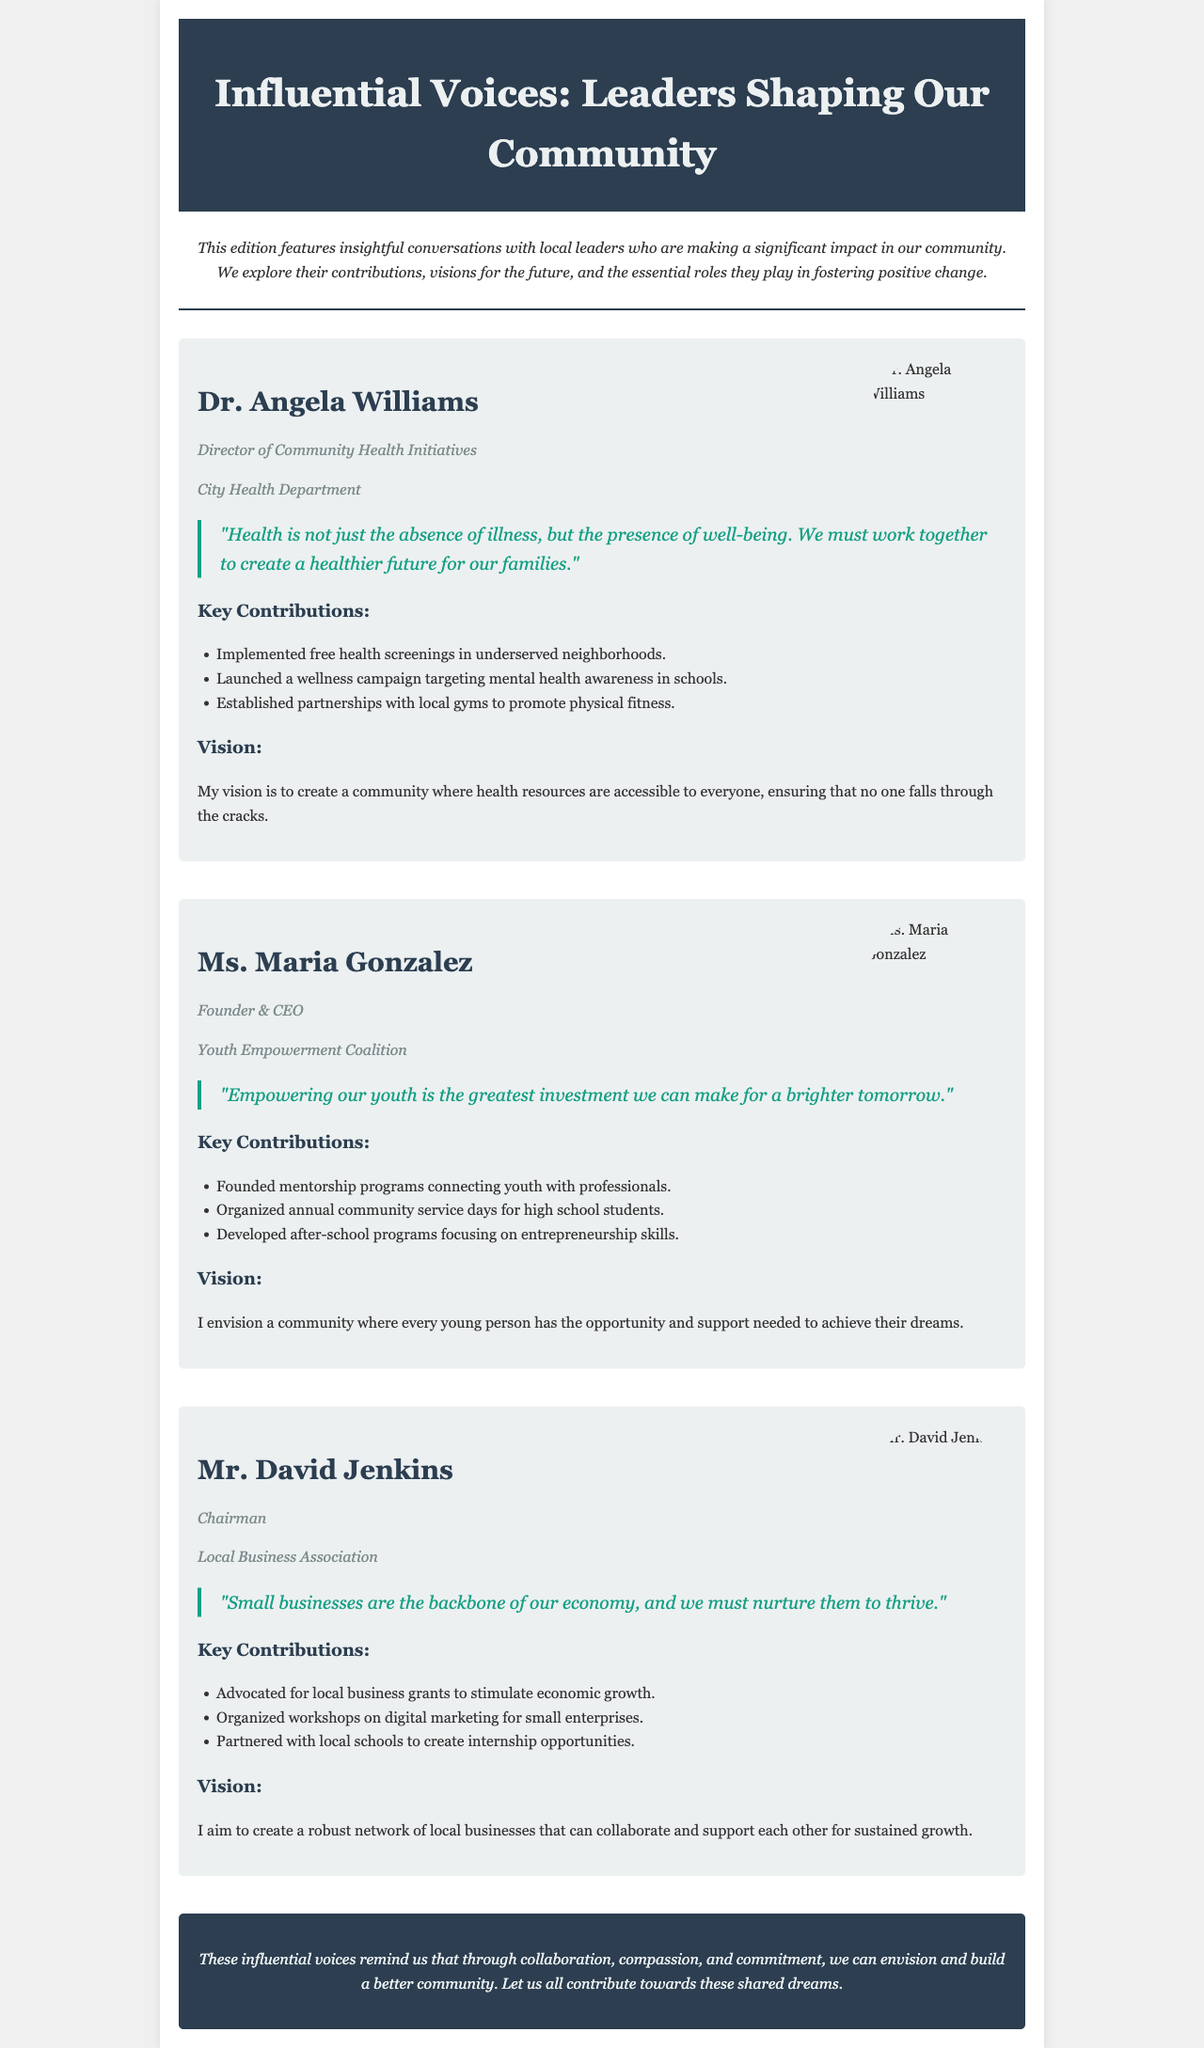What is the title of the newsletter? The title of the newsletter is found in the header section of the document.
Answer: Influential Voices: Leaders Shaping Our Community Who is the Director of Community Health Initiatives? This information is located in the section about Dr. Angela Williams.
Answer: Dr. Angela Williams What organization does Ms. Maria Gonzalez lead? The information about Ms. Maria Gonzalez's organization is provided in her interview section.
Answer: Youth Empowerment Coalition How many key contributions are listed for Mr. David Jenkins? The document states the contributions listed in Mr. David Jenkins's interview section.
Answer: Three What is Dr. Angela Williams's vision for the community? The vision is a quote from Dr. Angela Williams and can be found in her section.
Answer: A community where health resources are accessible to everyone What is the key quote from Ms. Maria Gonzalez? The key quote is given in Ms. Maria Gonzalez's interview section and captures her perspective.
Answer: "Empowering our youth is the greatest investment we can make for a brighter tomorrow." How does Mr. David Jenkins describe small businesses? This description can be found in the key quote section of Mr. David Jenkins's interview.
Answer: The backbone of our economy What style is the introduction written in? The style of writing for the introduction section is indicated in the document structure.
Answer: Italic Which interview contains a portrait of Dr. Angela Williams? This question refers to the specific section dedicated to Dr. Angela Williams in the newsletter.
Answer: Dr. Angela Williams 